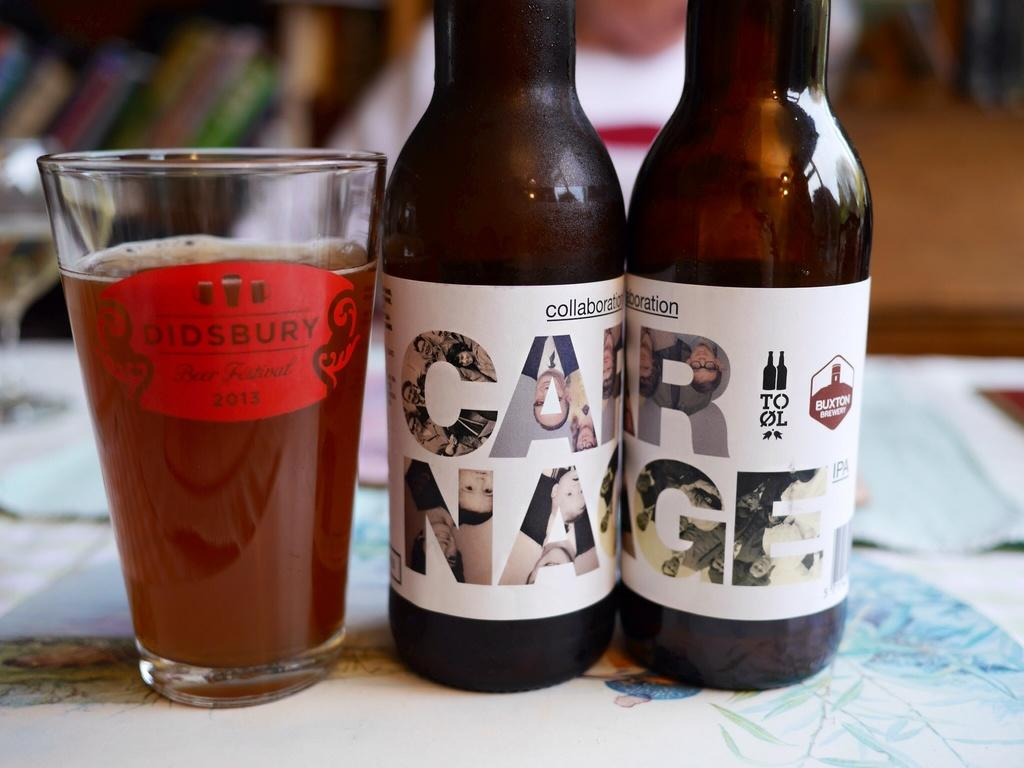<image>
Describe the image concisely. The glass has a Didsbury Beer Festival logo on it from 2013. 